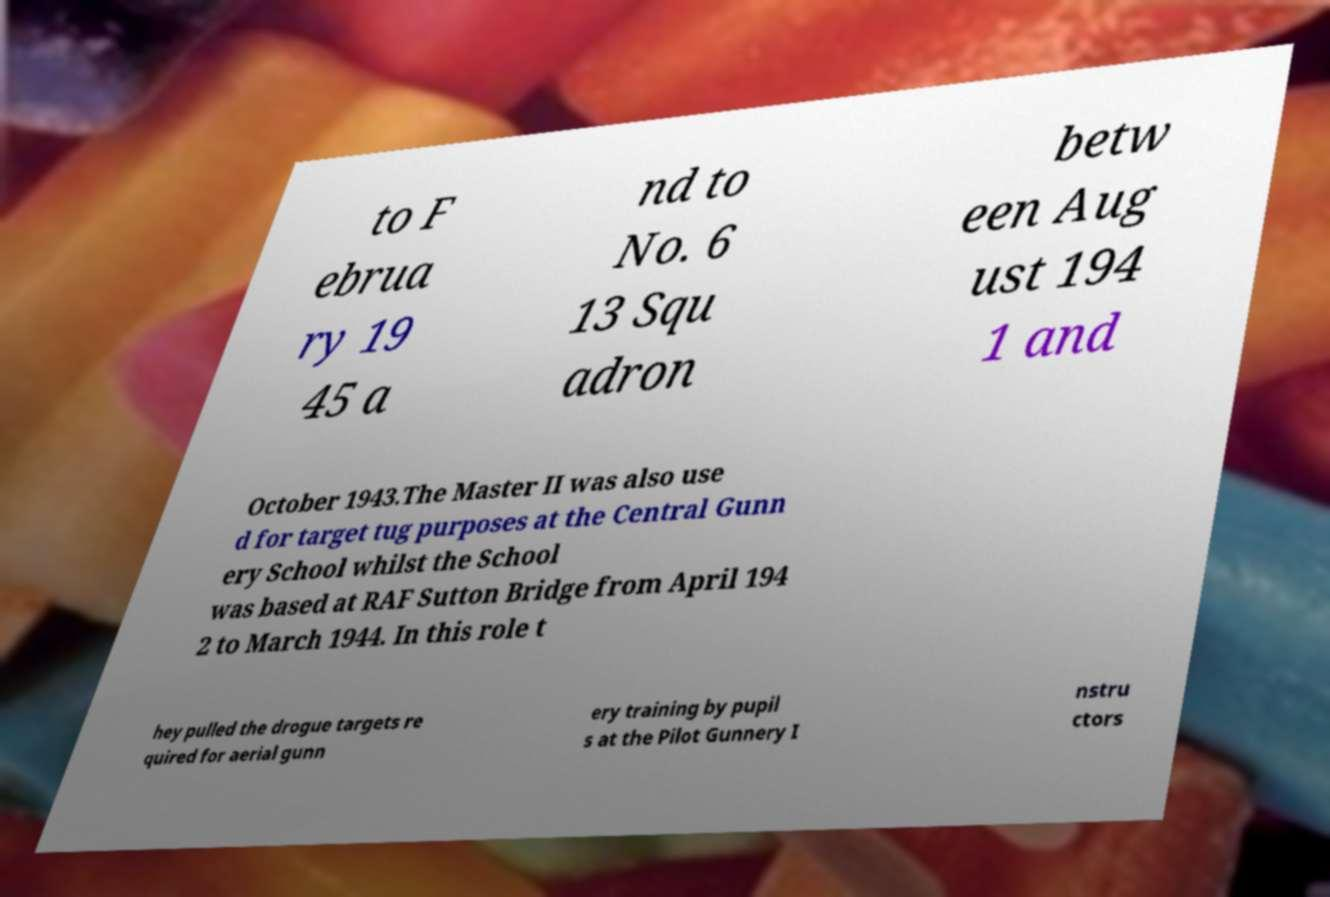For documentation purposes, I need the text within this image transcribed. Could you provide that? to F ebrua ry 19 45 a nd to No. 6 13 Squ adron betw een Aug ust 194 1 and October 1943.The Master II was also use d for target tug purposes at the Central Gunn ery School whilst the School was based at RAF Sutton Bridge from April 194 2 to March 1944. In this role t hey pulled the drogue targets re quired for aerial gunn ery training by pupil s at the Pilot Gunnery I nstru ctors 